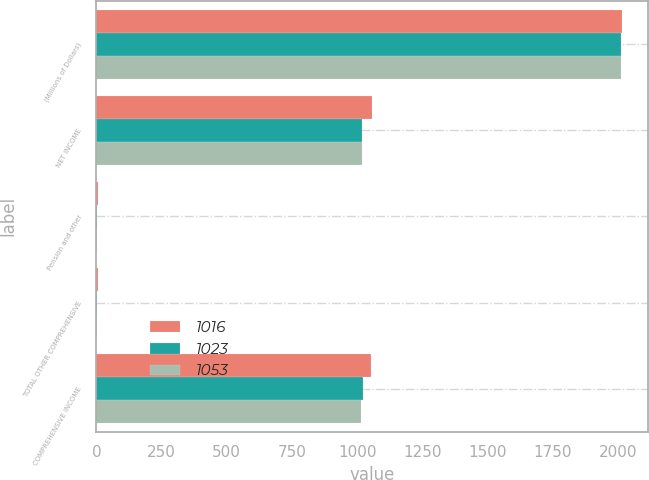<chart> <loc_0><loc_0><loc_500><loc_500><stacked_bar_chart><ecel><fcel>(Millions of Dollars)<fcel>NET INCOME<fcel>Pension and other<fcel>TOTAL OTHER COMPREHENSIVE<fcel>COMPREHENSIVE INCOME<nl><fcel>1016<fcel>2014<fcel>1058<fcel>5<fcel>5<fcel>1053<nl><fcel>1023<fcel>2013<fcel>1020<fcel>3<fcel>3<fcel>1023<nl><fcel>1053<fcel>2012<fcel>1017<fcel>1<fcel>1<fcel>1016<nl></chart> 